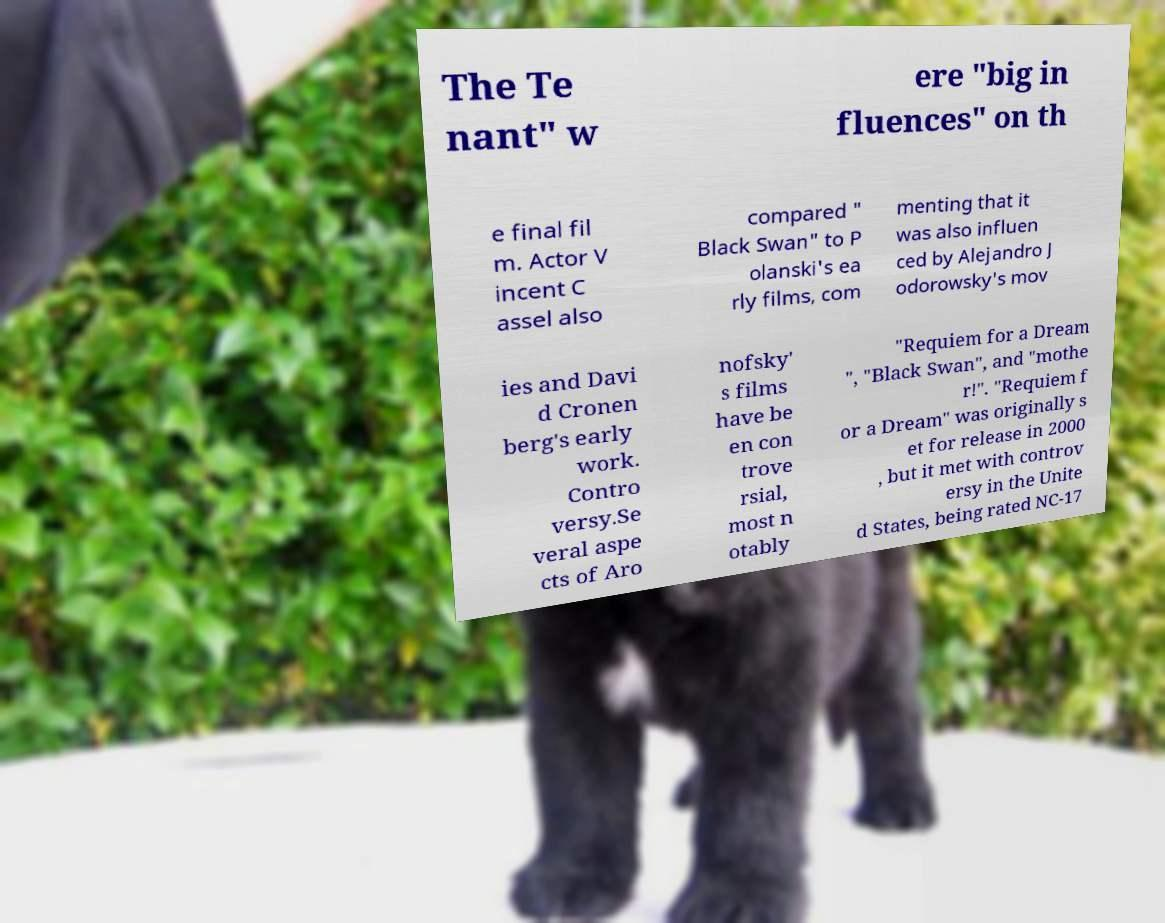Can you accurately transcribe the text from the provided image for me? The Te nant" w ere "big in fluences" on th e final fil m. Actor V incent C assel also compared " Black Swan" to P olanski's ea rly films, com menting that it was also influen ced by Alejandro J odorowsky's mov ies and Davi d Cronen berg's early work. Contro versy.Se veral aspe cts of Aro nofsky' s films have be en con trove rsial, most n otably "Requiem for a Dream ", "Black Swan", and "mothe r!". "Requiem f or a Dream" was originally s et for release in 2000 , but it met with controv ersy in the Unite d States, being rated NC-17 